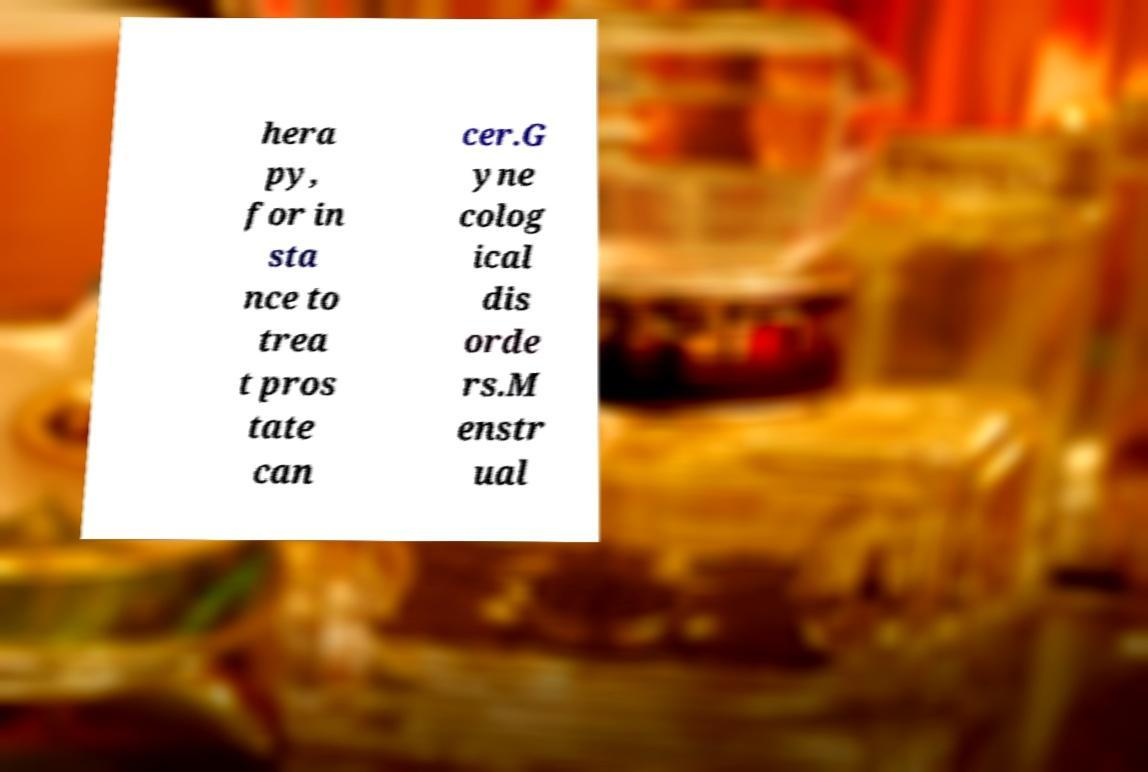Please identify and transcribe the text found in this image. hera py, for in sta nce to trea t pros tate can cer.G yne colog ical dis orde rs.M enstr ual 